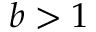Convert formula to latex. <formula><loc_0><loc_0><loc_500><loc_500>b > 1</formula> 